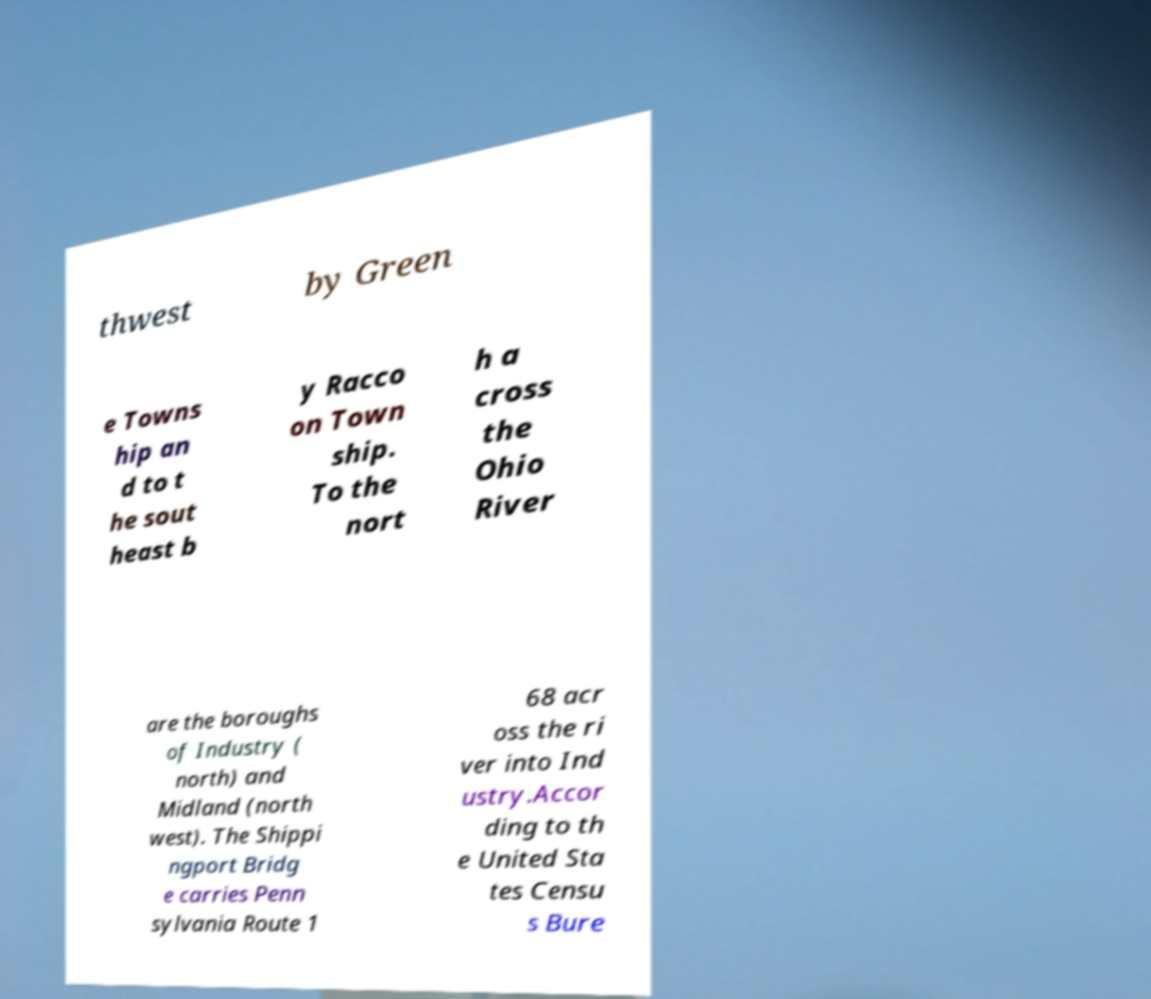There's text embedded in this image that I need extracted. Can you transcribe it verbatim? thwest by Green e Towns hip an d to t he sout heast b y Racco on Town ship. To the nort h a cross the Ohio River are the boroughs of Industry ( north) and Midland (north west). The Shippi ngport Bridg e carries Penn sylvania Route 1 68 acr oss the ri ver into Ind ustry.Accor ding to th e United Sta tes Censu s Bure 